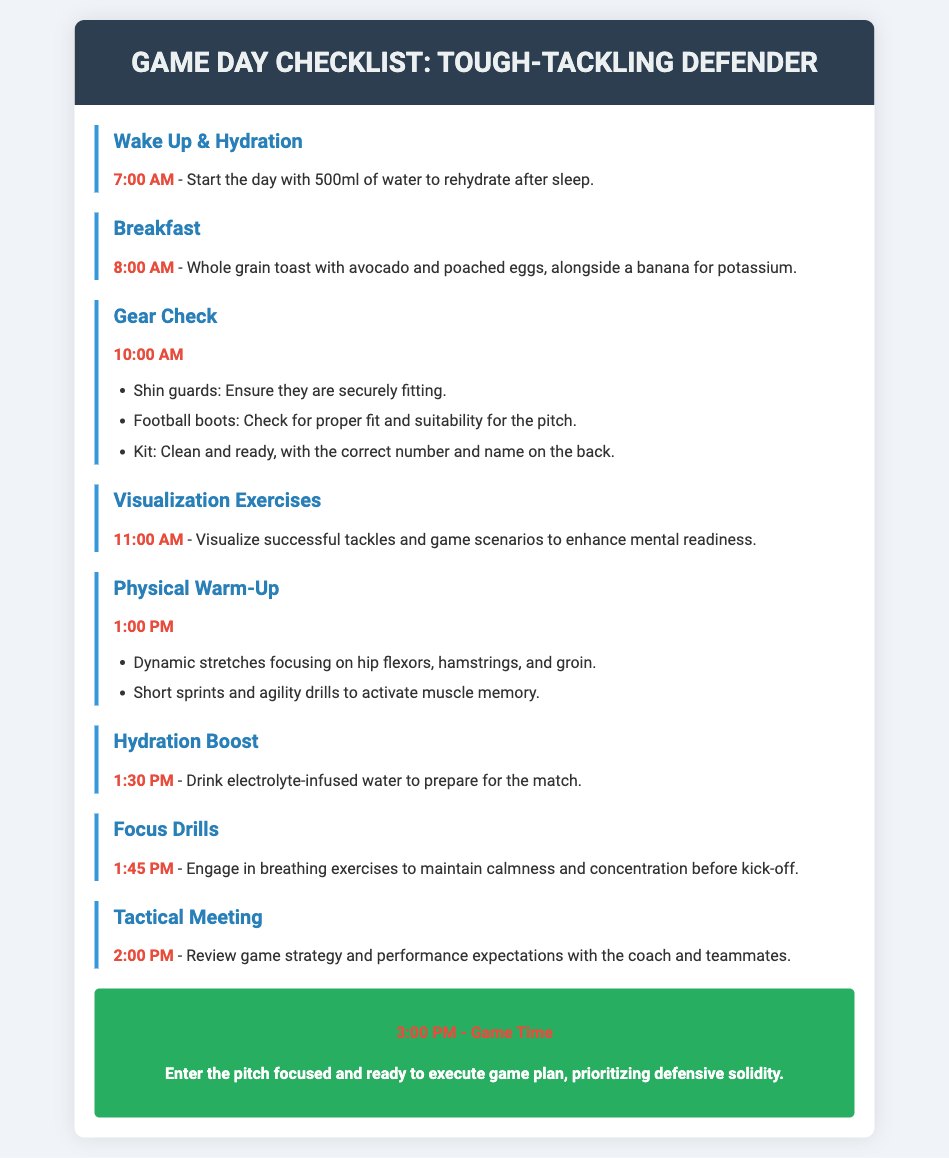what time should you wake up? The document states to wake up at 7:00 AM to start the day.
Answer: 7:00 AM what drink is recommended first thing in the morning? The checklist recommends drinking 500ml of water to rehydrate.
Answer: 500ml of water what should be consumed for breakfast? According to the agenda, breakfast should include whole grain toast with avocado and poached eggs, and a banana.
Answer: Whole grain toast with avocado and poached eggs, banana which item should ensure a secure fit during the gear check? The checklist mentions that shin guards should ensure they are securely fitting.
Answer: Shin guards what activity is scheduled at 11:00 AM? The agenda outlines visualization exercises to enhance mental readiness at this time.
Answer: Visualization exercises what is the focus of the tactical meeting? The tactical meeting is to review game strategy and performance expectations.
Answer: Game strategy and performance expectations what type of water should be consumed at 1:30 PM? At this time, hydration with electrolyte-infused water is recommended.
Answer: Electrolyte-infused water what key psychological method is suggested before kick-off? Breathing exercises are recommended to maintain calmness and concentration.
Answer: Breathing exercises what is the primary objective once on the pitch at game time? The document states to prioritize defensive solidity.
Answer: Defensive solidity 